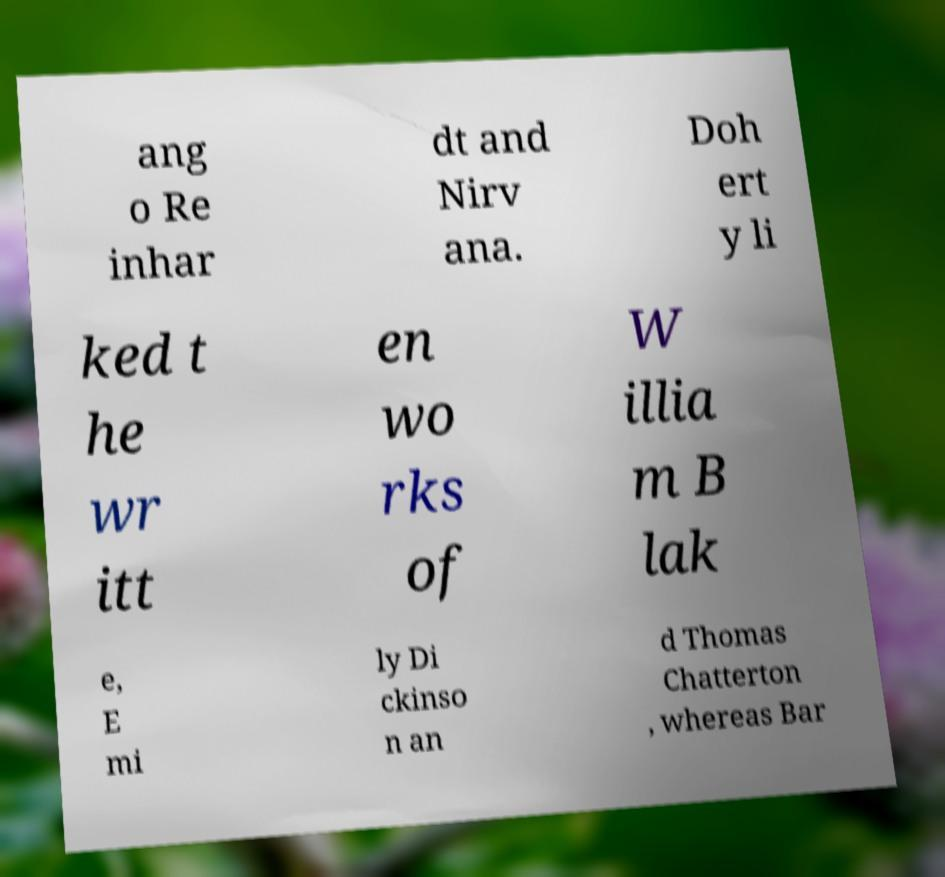Please read and relay the text visible in this image. What does it say? ang o Re inhar dt and Nirv ana. Doh ert y li ked t he wr itt en wo rks of W illia m B lak e, E mi ly Di ckinso n an d Thomas Chatterton , whereas Bar 